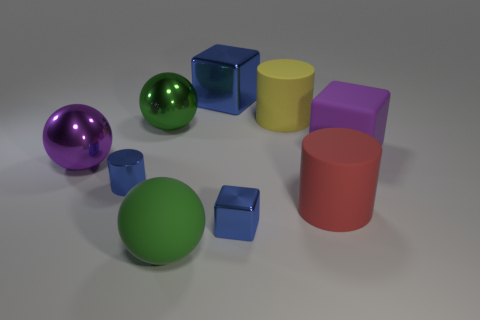Do the tiny block and the small cylinder have the same color?
Provide a succinct answer. Yes. There is a large sphere that is the same color as the large rubber cube; what material is it?
Offer a very short reply. Metal. There is a green sphere behind the large red rubber cylinder; are there any blocks that are left of it?
Ensure brevity in your answer.  No. There is another large thing that is the same shape as the large blue thing; what is it made of?
Your answer should be very brief. Rubber. Is the number of large purple rubber objects greater than the number of brown cylinders?
Your answer should be very brief. Yes. Is the color of the rubber block the same as the cylinder left of the tiny block?
Your answer should be very brief. No. There is a ball that is behind the metallic cylinder and on the right side of the purple metal thing; what is its color?
Ensure brevity in your answer.  Green. What number of other things are made of the same material as the large yellow thing?
Your answer should be compact. 3. Are there fewer red rubber cylinders than blue metallic cubes?
Your answer should be compact. Yes. Are the small blue cube and the big cube that is to the left of the big red rubber thing made of the same material?
Offer a very short reply. Yes. 